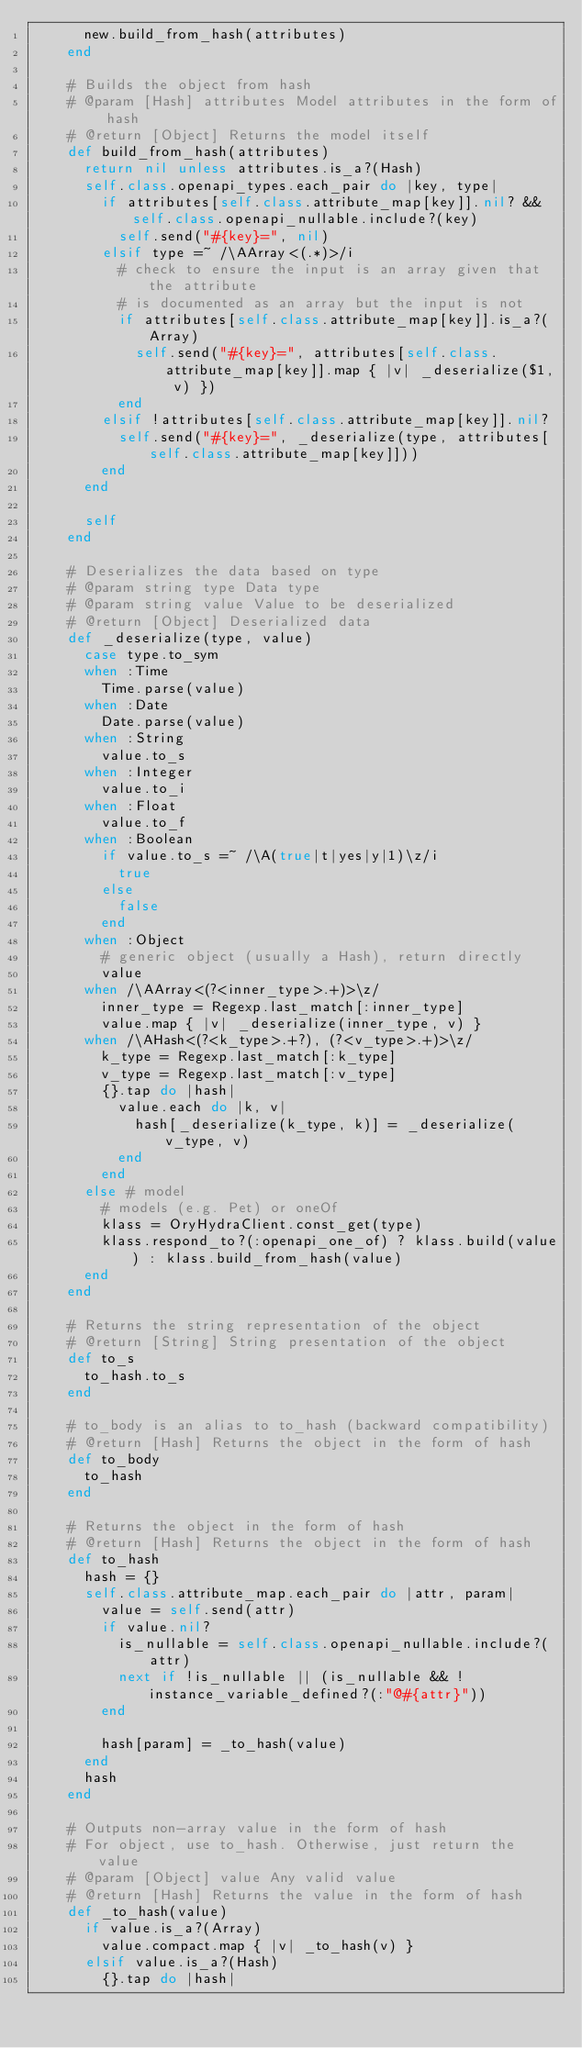Convert code to text. <code><loc_0><loc_0><loc_500><loc_500><_Ruby_>      new.build_from_hash(attributes)
    end

    # Builds the object from hash
    # @param [Hash] attributes Model attributes in the form of hash
    # @return [Object] Returns the model itself
    def build_from_hash(attributes)
      return nil unless attributes.is_a?(Hash)
      self.class.openapi_types.each_pair do |key, type|
        if attributes[self.class.attribute_map[key]].nil? && self.class.openapi_nullable.include?(key)
          self.send("#{key}=", nil)
        elsif type =~ /\AArray<(.*)>/i
          # check to ensure the input is an array given that the attribute
          # is documented as an array but the input is not
          if attributes[self.class.attribute_map[key]].is_a?(Array)
            self.send("#{key}=", attributes[self.class.attribute_map[key]].map { |v| _deserialize($1, v) })
          end
        elsif !attributes[self.class.attribute_map[key]].nil?
          self.send("#{key}=", _deserialize(type, attributes[self.class.attribute_map[key]]))
        end
      end

      self
    end

    # Deserializes the data based on type
    # @param string type Data type
    # @param string value Value to be deserialized
    # @return [Object] Deserialized data
    def _deserialize(type, value)
      case type.to_sym
      when :Time
        Time.parse(value)
      when :Date
        Date.parse(value)
      when :String
        value.to_s
      when :Integer
        value.to_i
      when :Float
        value.to_f
      when :Boolean
        if value.to_s =~ /\A(true|t|yes|y|1)\z/i
          true
        else
          false
        end
      when :Object
        # generic object (usually a Hash), return directly
        value
      when /\AArray<(?<inner_type>.+)>\z/
        inner_type = Regexp.last_match[:inner_type]
        value.map { |v| _deserialize(inner_type, v) }
      when /\AHash<(?<k_type>.+?), (?<v_type>.+)>\z/
        k_type = Regexp.last_match[:k_type]
        v_type = Regexp.last_match[:v_type]
        {}.tap do |hash|
          value.each do |k, v|
            hash[_deserialize(k_type, k)] = _deserialize(v_type, v)
          end
        end
      else # model
        # models (e.g. Pet) or oneOf
        klass = OryHydraClient.const_get(type)
        klass.respond_to?(:openapi_one_of) ? klass.build(value) : klass.build_from_hash(value)
      end
    end

    # Returns the string representation of the object
    # @return [String] String presentation of the object
    def to_s
      to_hash.to_s
    end

    # to_body is an alias to to_hash (backward compatibility)
    # @return [Hash] Returns the object in the form of hash
    def to_body
      to_hash
    end

    # Returns the object in the form of hash
    # @return [Hash] Returns the object in the form of hash
    def to_hash
      hash = {}
      self.class.attribute_map.each_pair do |attr, param|
        value = self.send(attr)
        if value.nil?
          is_nullable = self.class.openapi_nullable.include?(attr)
          next if !is_nullable || (is_nullable && !instance_variable_defined?(:"@#{attr}"))
        end

        hash[param] = _to_hash(value)
      end
      hash
    end

    # Outputs non-array value in the form of hash
    # For object, use to_hash. Otherwise, just return the value
    # @param [Object] value Any valid value
    # @return [Hash] Returns the value in the form of hash
    def _to_hash(value)
      if value.is_a?(Array)
        value.compact.map { |v| _to_hash(v) }
      elsif value.is_a?(Hash)
        {}.tap do |hash|</code> 